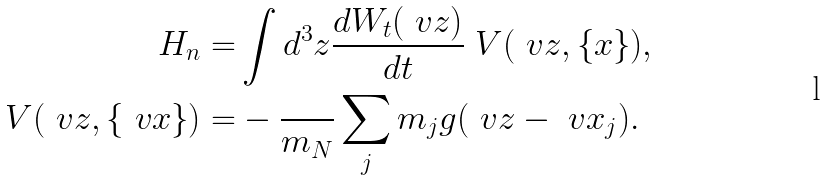<formula> <loc_0><loc_0><loc_500><loc_500>H _ { n } = & \int d ^ { 3 } z \frac { d W _ { t } ( \ v z ) } { d t } \ V ( \ v z , \{ x \} ) , \\ \ V ( \ v z , \{ \ v x \} ) = & - \frac { } { m _ { N } } \sum _ { j } m _ { j } g ( \ v z - \ v x _ { j } ) .</formula> 